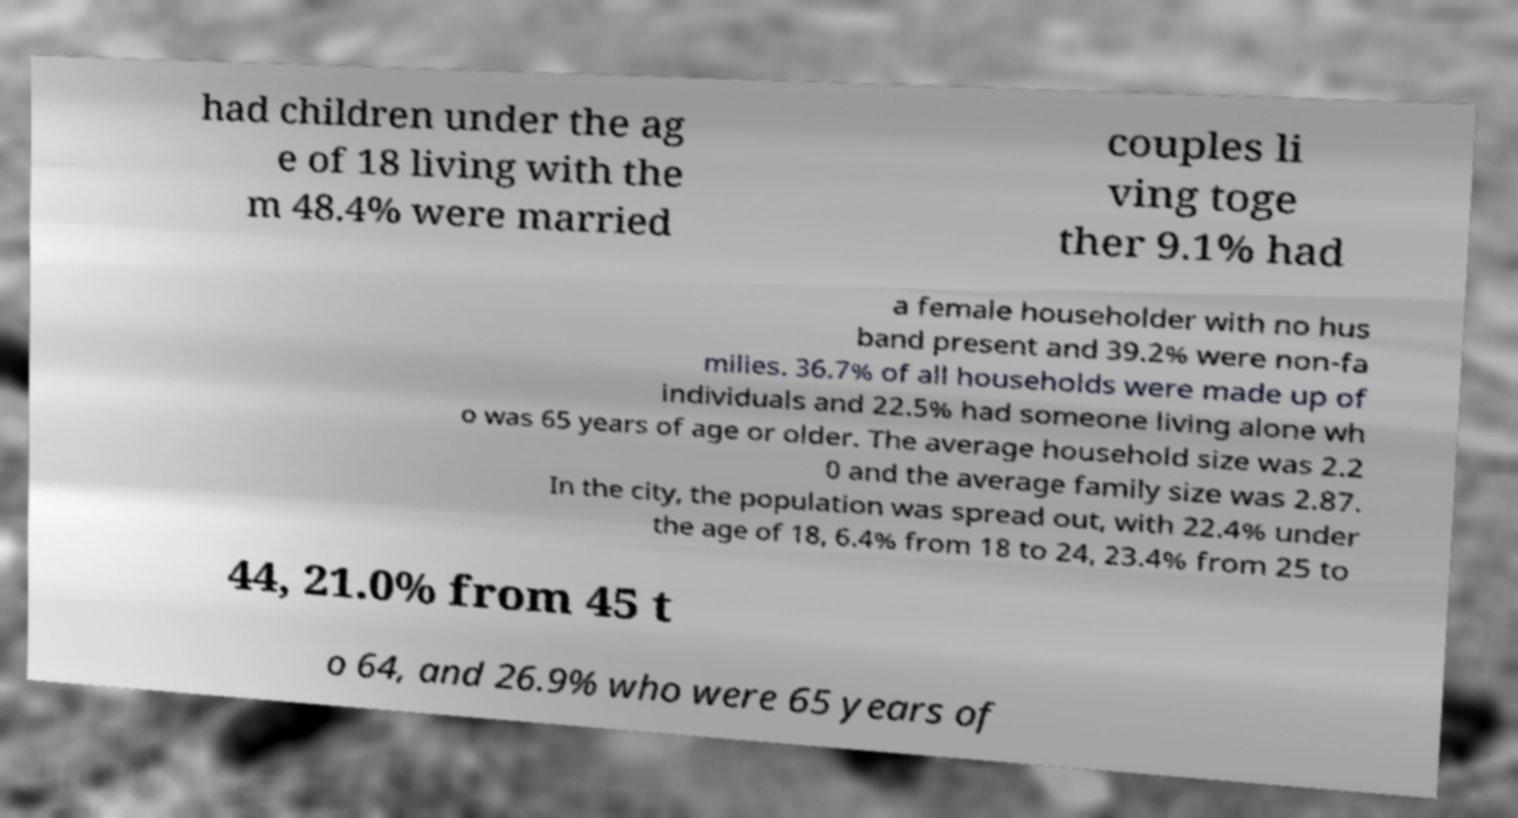Please identify and transcribe the text found in this image. had children under the ag e of 18 living with the m 48.4% were married couples li ving toge ther 9.1% had a female householder with no hus band present and 39.2% were non-fa milies. 36.7% of all households were made up of individuals and 22.5% had someone living alone wh o was 65 years of age or older. The average household size was 2.2 0 and the average family size was 2.87. In the city, the population was spread out, with 22.4% under the age of 18, 6.4% from 18 to 24, 23.4% from 25 to 44, 21.0% from 45 t o 64, and 26.9% who were 65 years of 